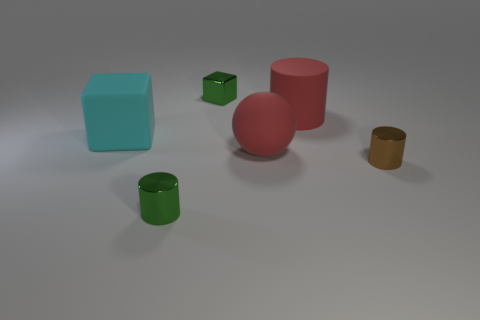Subtract all red rubber cylinders. How many cylinders are left? 2 Add 2 large red balls. How many objects exist? 8 Subtract all brown cylinders. How many cylinders are left? 2 Subtract 0 brown cubes. How many objects are left? 6 Subtract all balls. How many objects are left? 5 Subtract 1 spheres. How many spheres are left? 0 Subtract all green cubes. Subtract all gray cylinders. How many cubes are left? 1 Subtract all gray balls. How many red cylinders are left? 1 Subtract all tiny blue balls. Subtract all shiny blocks. How many objects are left? 5 Add 3 small cylinders. How many small cylinders are left? 5 